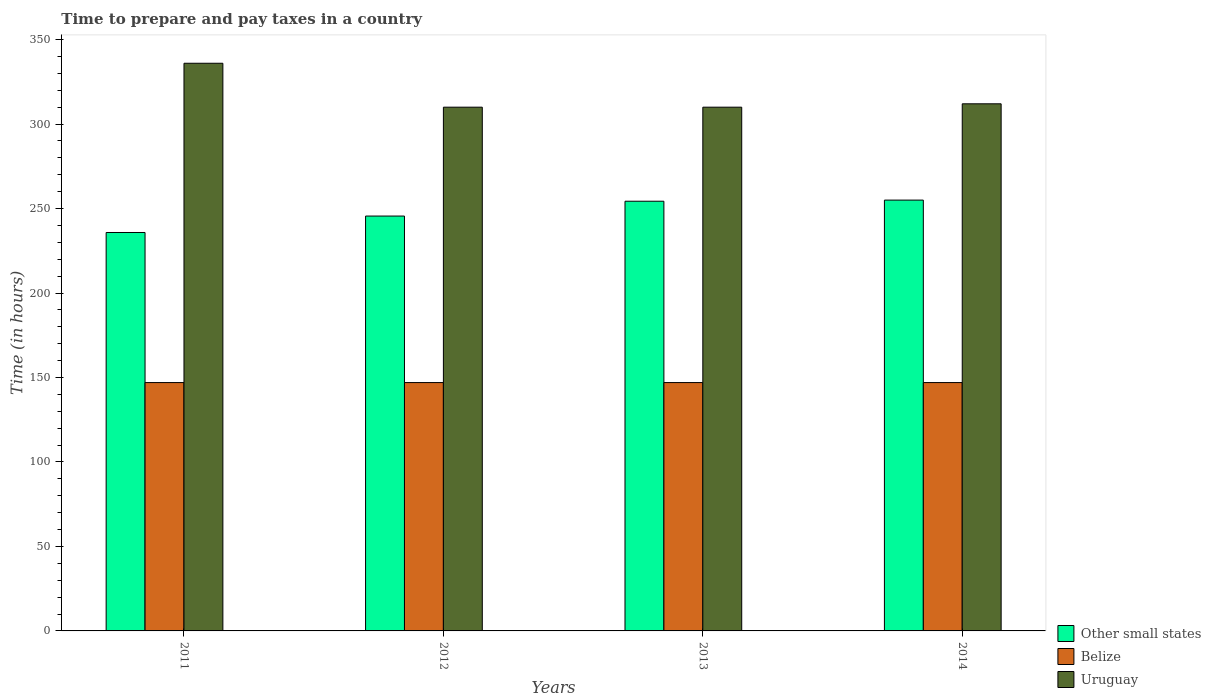How many different coloured bars are there?
Give a very brief answer. 3. How many groups of bars are there?
Ensure brevity in your answer.  4. Are the number of bars per tick equal to the number of legend labels?
Provide a short and direct response. Yes. Are the number of bars on each tick of the X-axis equal?
Your answer should be compact. Yes. What is the number of hours required to prepare and pay taxes in Uruguay in 2011?
Keep it short and to the point. 336. Across all years, what is the maximum number of hours required to prepare and pay taxes in Other small states?
Offer a terse response. 255. Across all years, what is the minimum number of hours required to prepare and pay taxes in Other small states?
Your answer should be compact. 235.83. What is the total number of hours required to prepare and pay taxes in Belize in the graph?
Your answer should be compact. 588. What is the difference between the number of hours required to prepare and pay taxes in Uruguay in 2012 and that in 2014?
Offer a very short reply. -2. What is the difference between the number of hours required to prepare and pay taxes in Uruguay in 2011 and the number of hours required to prepare and pay taxes in Other small states in 2012?
Make the answer very short. 90.44. What is the average number of hours required to prepare and pay taxes in Uruguay per year?
Offer a terse response. 317. In the year 2014, what is the difference between the number of hours required to prepare and pay taxes in Belize and number of hours required to prepare and pay taxes in Other small states?
Make the answer very short. -108. In how many years, is the number of hours required to prepare and pay taxes in Other small states greater than 140 hours?
Your response must be concise. 4. What is the ratio of the number of hours required to prepare and pay taxes in Other small states in 2013 to that in 2014?
Your answer should be compact. 1. Is the number of hours required to prepare and pay taxes in Other small states in 2011 less than that in 2012?
Provide a succinct answer. Yes. What is the difference between the highest and the second highest number of hours required to prepare and pay taxes in Uruguay?
Make the answer very short. 24. What is the difference between the highest and the lowest number of hours required to prepare and pay taxes in Other small states?
Provide a short and direct response. 19.17. In how many years, is the number of hours required to prepare and pay taxes in Uruguay greater than the average number of hours required to prepare and pay taxes in Uruguay taken over all years?
Offer a terse response. 1. What does the 3rd bar from the left in 2012 represents?
Offer a terse response. Uruguay. What does the 1st bar from the right in 2013 represents?
Provide a short and direct response. Uruguay. Does the graph contain any zero values?
Keep it short and to the point. No. Does the graph contain grids?
Keep it short and to the point. No. How many legend labels are there?
Offer a terse response. 3. How are the legend labels stacked?
Provide a short and direct response. Vertical. What is the title of the graph?
Ensure brevity in your answer.  Time to prepare and pay taxes in a country. What is the label or title of the X-axis?
Your answer should be compact. Years. What is the label or title of the Y-axis?
Offer a terse response. Time (in hours). What is the Time (in hours) of Other small states in 2011?
Your response must be concise. 235.83. What is the Time (in hours) of Belize in 2011?
Your response must be concise. 147. What is the Time (in hours) of Uruguay in 2011?
Offer a terse response. 336. What is the Time (in hours) in Other small states in 2012?
Provide a short and direct response. 245.56. What is the Time (in hours) of Belize in 2012?
Your answer should be very brief. 147. What is the Time (in hours) of Uruguay in 2012?
Your answer should be compact. 310. What is the Time (in hours) in Other small states in 2013?
Offer a very short reply. 254.33. What is the Time (in hours) in Belize in 2013?
Your answer should be very brief. 147. What is the Time (in hours) in Uruguay in 2013?
Make the answer very short. 310. What is the Time (in hours) in Other small states in 2014?
Offer a very short reply. 255. What is the Time (in hours) in Belize in 2014?
Keep it short and to the point. 147. What is the Time (in hours) in Uruguay in 2014?
Offer a terse response. 312. Across all years, what is the maximum Time (in hours) in Other small states?
Give a very brief answer. 255. Across all years, what is the maximum Time (in hours) in Belize?
Offer a very short reply. 147. Across all years, what is the maximum Time (in hours) of Uruguay?
Offer a very short reply. 336. Across all years, what is the minimum Time (in hours) of Other small states?
Give a very brief answer. 235.83. Across all years, what is the minimum Time (in hours) in Belize?
Offer a very short reply. 147. Across all years, what is the minimum Time (in hours) in Uruguay?
Give a very brief answer. 310. What is the total Time (in hours) in Other small states in the graph?
Provide a succinct answer. 990.72. What is the total Time (in hours) of Belize in the graph?
Make the answer very short. 588. What is the total Time (in hours) of Uruguay in the graph?
Offer a very short reply. 1268. What is the difference between the Time (in hours) of Other small states in 2011 and that in 2012?
Give a very brief answer. -9.72. What is the difference between the Time (in hours) of Other small states in 2011 and that in 2013?
Give a very brief answer. -18.5. What is the difference between the Time (in hours) in Belize in 2011 and that in 2013?
Make the answer very short. 0. What is the difference between the Time (in hours) of Uruguay in 2011 and that in 2013?
Your response must be concise. 26. What is the difference between the Time (in hours) in Other small states in 2011 and that in 2014?
Provide a short and direct response. -19.17. What is the difference between the Time (in hours) in Uruguay in 2011 and that in 2014?
Make the answer very short. 24. What is the difference between the Time (in hours) of Other small states in 2012 and that in 2013?
Provide a succinct answer. -8.78. What is the difference between the Time (in hours) of Other small states in 2012 and that in 2014?
Provide a succinct answer. -9.44. What is the difference between the Time (in hours) of Belize in 2013 and that in 2014?
Give a very brief answer. 0. What is the difference between the Time (in hours) in Uruguay in 2013 and that in 2014?
Offer a terse response. -2. What is the difference between the Time (in hours) in Other small states in 2011 and the Time (in hours) in Belize in 2012?
Offer a very short reply. 88.83. What is the difference between the Time (in hours) in Other small states in 2011 and the Time (in hours) in Uruguay in 2012?
Give a very brief answer. -74.17. What is the difference between the Time (in hours) of Belize in 2011 and the Time (in hours) of Uruguay in 2012?
Give a very brief answer. -163. What is the difference between the Time (in hours) of Other small states in 2011 and the Time (in hours) of Belize in 2013?
Ensure brevity in your answer.  88.83. What is the difference between the Time (in hours) of Other small states in 2011 and the Time (in hours) of Uruguay in 2013?
Keep it short and to the point. -74.17. What is the difference between the Time (in hours) of Belize in 2011 and the Time (in hours) of Uruguay in 2013?
Offer a terse response. -163. What is the difference between the Time (in hours) of Other small states in 2011 and the Time (in hours) of Belize in 2014?
Ensure brevity in your answer.  88.83. What is the difference between the Time (in hours) in Other small states in 2011 and the Time (in hours) in Uruguay in 2014?
Offer a terse response. -76.17. What is the difference between the Time (in hours) in Belize in 2011 and the Time (in hours) in Uruguay in 2014?
Make the answer very short. -165. What is the difference between the Time (in hours) in Other small states in 2012 and the Time (in hours) in Belize in 2013?
Ensure brevity in your answer.  98.56. What is the difference between the Time (in hours) of Other small states in 2012 and the Time (in hours) of Uruguay in 2013?
Your answer should be compact. -64.44. What is the difference between the Time (in hours) of Belize in 2012 and the Time (in hours) of Uruguay in 2013?
Ensure brevity in your answer.  -163. What is the difference between the Time (in hours) in Other small states in 2012 and the Time (in hours) in Belize in 2014?
Provide a short and direct response. 98.56. What is the difference between the Time (in hours) of Other small states in 2012 and the Time (in hours) of Uruguay in 2014?
Provide a succinct answer. -66.44. What is the difference between the Time (in hours) of Belize in 2012 and the Time (in hours) of Uruguay in 2014?
Your answer should be very brief. -165. What is the difference between the Time (in hours) in Other small states in 2013 and the Time (in hours) in Belize in 2014?
Ensure brevity in your answer.  107.33. What is the difference between the Time (in hours) of Other small states in 2013 and the Time (in hours) of Uruguay in 2014?
Your answer should be very brief. -57.67. What is the difference between the Time (in hours) of Belize in 2013 and the Time (in hours) of Uruguay in 2014?
Your answer should be compact. -165. What is the average Time (in hours) in Other small states per year?
Ensure brevity in your answer.  247.68. What is the average Time (in hours) in Belize per year?
Your response must be concise. 147. What is the average Time (in hours) of Uruguay per year?
Your answer should be very brief. 317. In the year 2011, what is the difference between the Time (in hours) in Other small states and Time (in hours) in Belize?
Your answer should be very brief. 88.83. In the year 2011, what is the difference between the Time (in hours) in Other small states and Time (in hours) in Uruguay?
Your response must be concise. -100.17. In the year 2011, what is the difference between the Time (in hours) of Belize and Time (in hours) of Uruguay?
Offer a very short reply. -189. In the year 2012, what is the difference between the Time (in hours) of Other small states and Time (in hours) of Belize?
Offer a very short reply. 98.56. In the year 2012, what is the difference between the Time (in hours) of Other small states and Time (in hours) of Uruguay?
Ensure brevity in your answer.  -64.44. In the year 2012, what is the difference between the Time (in hours) of Belize and Time (in hours) of Uruguay?
Keep it short and to the point. -163. In the year 2013, what is the difference between the Time (in hours) of Other small states and Time (in hours) of Belize?
Provide a succinct answer. 107.33. In the year 2013, what is the difference between the Time (in hours) in Other small states and Time (in hours) in Uruguay?
Your answer should be very brief. -55.67. In the year 2013, what is the difference between the Time (in hours) of Belize and Time (in hours) of Uruguay?
Provide a succinct answer. -163. In the year 2014, what is the difference between the Time (in hours) of Other small states and Time (in hours) of Belize?
Your answer should be compact. 108. In the year 2014, what is the difference between the Time (in hours) in Other small states and Time (in hours) in Uruguay?
Offer a very short reply. -57. In the year 2014, what is the difference between the Time (in hours) in Belize and Time (in hours) in Uruguay?
Keep it short and to the point. -165. What is the ratio of the Time (in hours) of Other small states in 2011 to that in 2012?
Keep it short and to the point. 0.96. What is the ratio of the Time (in hours) in Uruguay in 2011 to that in 2012?
Your response must be concise. 1.08. What is the ratio of the Time (in hours) in Other small states in 2011 to that in 2013?
Provide a short and direct response. 0.93. What is the ratio of the Time (in hours) of Belize in 2011 to that in 2013?
Give a very brief answer. 1. What is the ratio of the Time (in hours) of Uruguay in 2011 to that in 2013?
Ensure brevity in your answer.  1.08. What is the ratio of the Time (in hours) of Other small states in 2011 to that in 2014?
Your answer should be compact. 0.92. What is the ratio of the Time (in hours) in Belize in 2011 to that in 2014?
Your answer should be compact. 1. What is the ratio of the Time (in hours) in Uruguay in 2011 to that in 2014?
Your answer should be very brief. 1.08. What is the ratio of the Time (in hours) of Other small states in 2012 to that in 2013?
Your response must be concise. 0.97. What is the ratio of the Time (in hours) of Belize in 2012 to that in 2013?
Your answer should be compact. 1. What is the ratio of the Time (in hours) in Other small states in 2012 to that in 2014?
Offer a very short reply. 0.96. What is the ratio of the Time (in hours) of Uruguay in 2012 to that in 2014?
Provide a succinct answer. 0.99. What is the ratio of the Time (in hours) of Other small states in 2013 to that in 2014?
Provide a short and direct response. 1. What is the ratio of the Time (in hours) in Belize in 2013 to that in 2014?
Keep it short and to the point. 1. What is the ratio of the Time (in hours) of Uruguay in 2013 to that in 2014?
Keep it short and to the point. 0.99. What is the difference between the highest and the second highest Time (in hours) of Belize?
Provide a short and direct response. 0. What is the difference between the highest and the lowest Time (in hours) of Other small states?
Your answer should be compact. 19.17. What is the difference between the highest and the lowest Time (in hours) in Belize?
Keep it short and to the point. 0. 